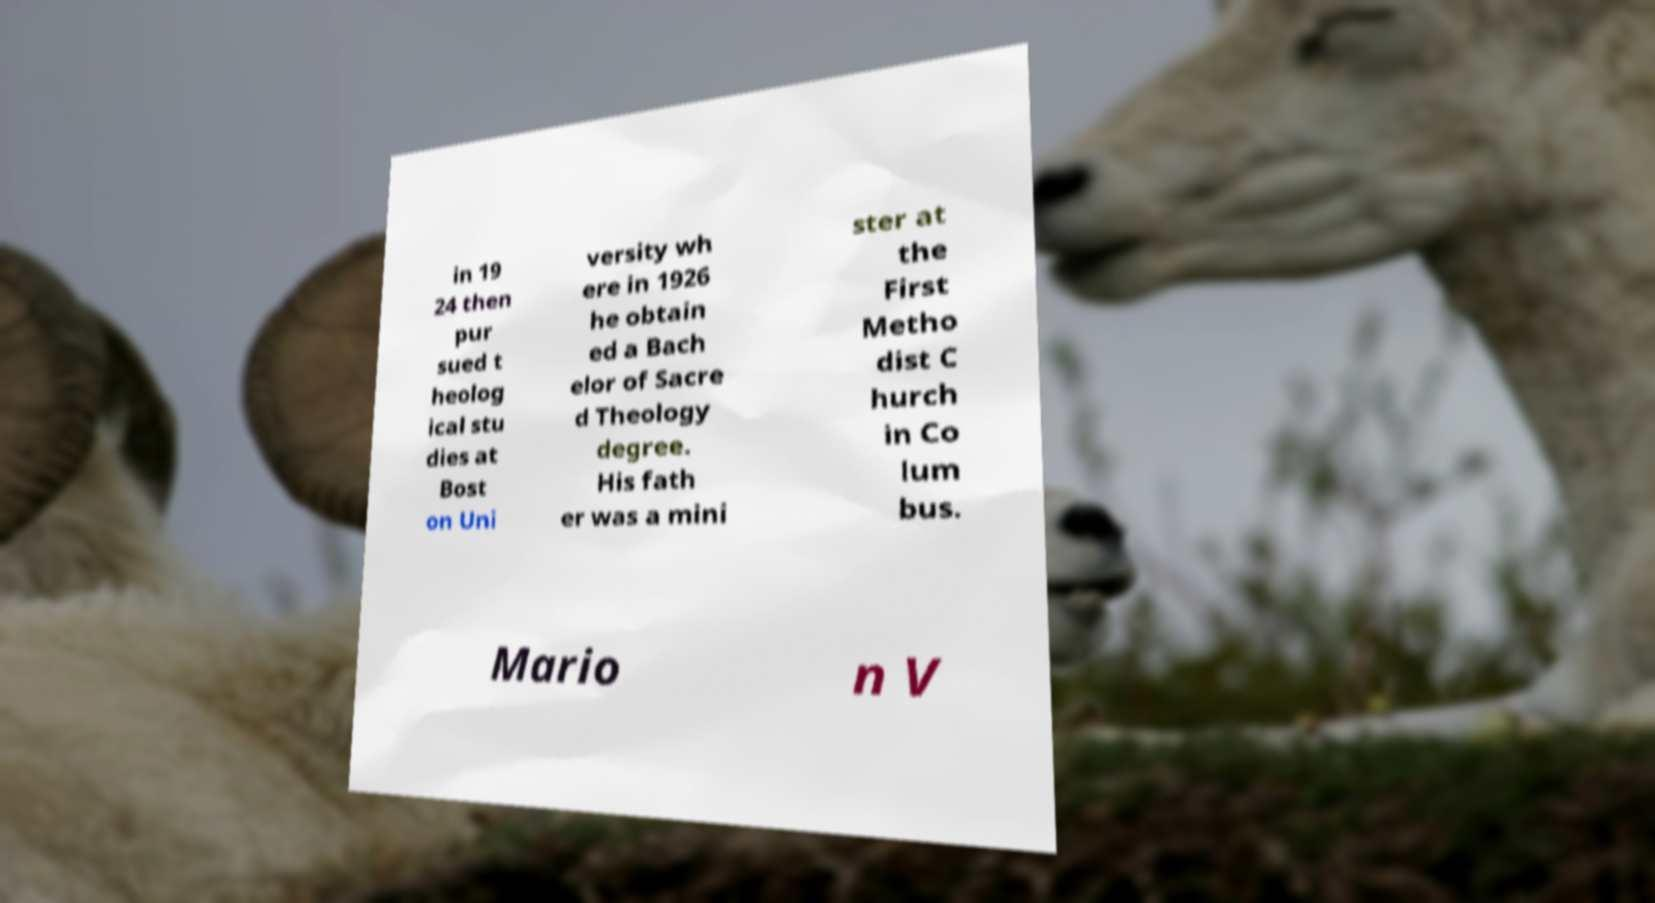Please identify and transcribe the text found in this image. in 19 24 then pur sued t heolog ical stu dies at Bost on Uni versity wh ere in 1926 he obtain ed a Bach elor of Sacre d Theology degree. His fath er was a mini ster at the First Metho dist C hurch in Co lum bus. Mario n V 